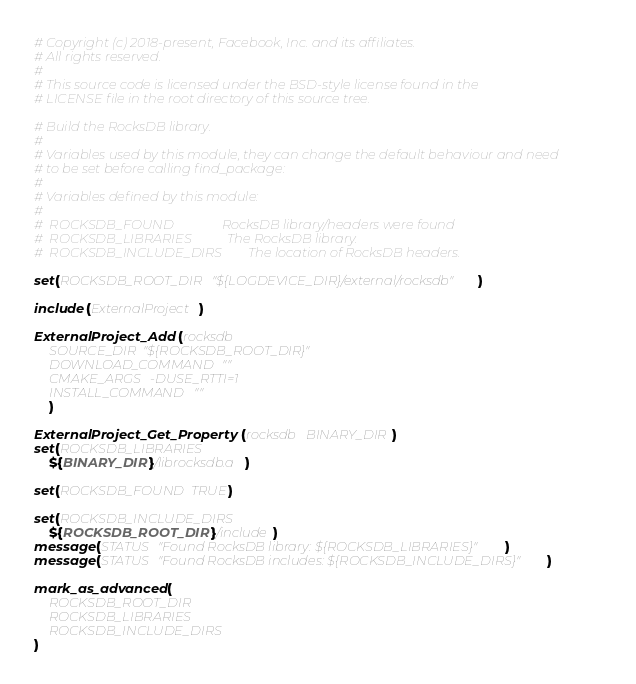Convert code to text. <code><loc_0><loc_0><loc_500><loc_500><_CMake_># Copyright (c) 2018-present, Facebook, Inc. and its affiliates.
# All rights reserved.
#
# This source code is licensed under the BSD-style license found in the
# LICENSE file in the root directory of this source tree.

# Build the RocksDB library.
#
# Variables used by this module, they can change the default behaviour and need
# to be set before calling find_package:
#
# Variables defined by this module:
#
#  ROCKSDB_FOUND               RocksDB library/headers were found
#  ROCKSDB_LIBRARIES           The RocksDB library.
#  ROCKSDB_INCLUDE_DIRS        The location of RocksDB headers.

set(ROCKSDB_ROOT_DIR "${LOGDEVICE_DIR}/external/rocksdb")

include(ExternalProject)

ExternalProject_Add(rocksdb
    SOURCE_DIR "${ROCKSDB_ROOT_DIR}"
    DOWNLOAD_COMMAND ""
    CMAKE_ARGS -DUSE_RTTI=1
    INSTALL_COMMAND ""
    )

ExternalProject_Get_Property(rocksdb BINARY_DIR)
set(ROCKSDB_LIBRARIES
    ${BINARY_DIR}/librocksdb.a)

set(ROCKSDB_FOUND TRUE)

set(ROCKSDB_INCLUDE_DIRS
    ${ROCKSDB_ROOT_DIR}/include)
message(STATUS "Found RocksDB library: ${ROCKSDB_LIBRARIES}")
message(STATUS "Found RocksDB includes: ${ROCKSDB_INCLUDE_DIRS}")

mark_as_advanced(
    ROCKSDB_ROOT_DIR
    ROCKSDB_LIBRARIES
    ROCKSDB_INCLUDE_DIRS
)
</code> 